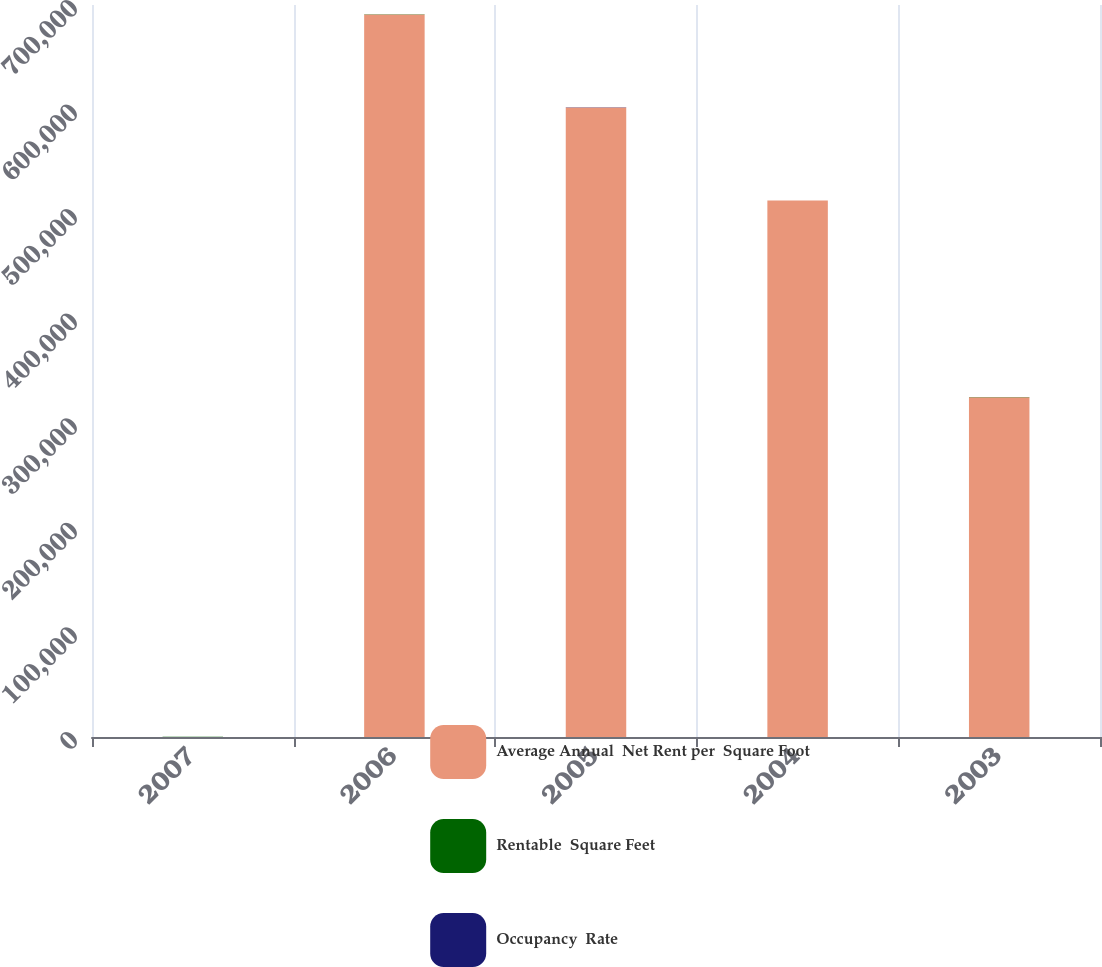<chart> <loc_0><loc_0><loc_500><loc_500><stacked_bar_chart><ecel><fcel>2007<fcel>2006<fcel>2005<fcel>2004<fcel>2003<nl><fcel>Average Annual  Net Rent per  Square Foot<fcel>90.38<fcel>691000<fcel>602000<fcel>513000<fcel>325000<nl><fcel>Rentable  Square Feet<fcel>86.8<fcel>83.6<fcel>90.9<fcel>88.7<fcel>98.3<nl><fcel>Occupancy  Rate<fcel>89.86<fcel>83.53<fcel>81.94<fcel>72.81<fcel>112.77<nl></chart> 